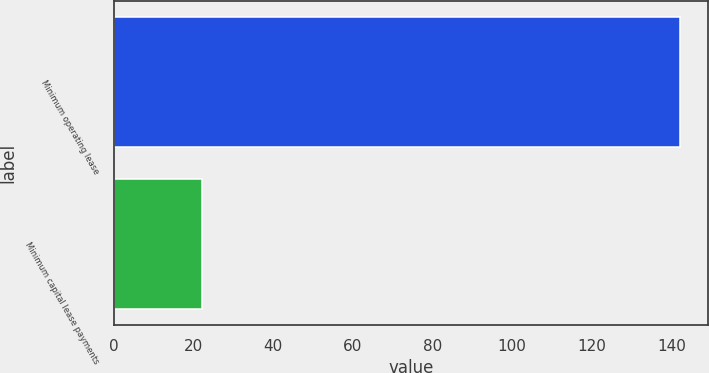<chart> <loc_0><loc_0><loc_500><loc_500><bar_chart><fcel>Minimum operating lease<fcel>Minimum capital lease payments<nl><fcel>142<fcel>22<nl></chart> 